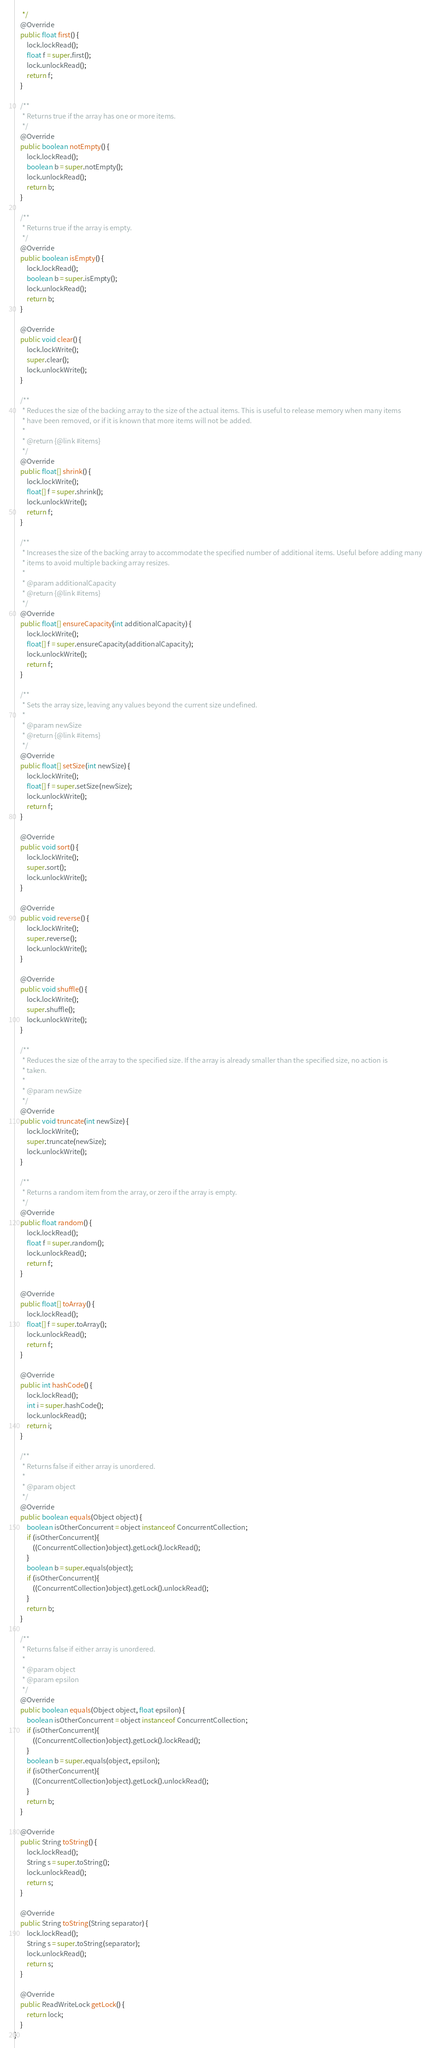<code> <loc_0><loc_0><loc_500><loc_500><_Java_>     */
    @Override
    public float first() {
        lock.lockRead();
        float f = super.first();
        lock.unlockRead();
        return f;
    }

    /**
     * Returns true if the array has one or more items.
     */
    @Override
    public boolean notEmpty() {
        lock.lockRead();
        boolean b = super.notEmpty();
        lock.unlockRead();
        return b;
    }

    /**
     * Returns true if the array is empty.
     */
    @Override
    public boolean isEmpty() {
        lock.lockRead();
        boolean b = super.isEmpty();
        lock.unlockRead();
        return b;
    }

    @Override
    public void clear() {
        lock.lockWrite();
        super.clear();
        lock.unlockWrite();
    }

    /**
     * Reduces the size of the backing array to the size of the actual items. This is useful to release memory when many items
     * have been removed, or if it is known that more items will not be added.
     *
     * @return {@link #items}
     */
    @Override
    public float[] shrink() {
        lock.lockWrite();
        float[] f = super.shrink();
        lock.unlockWrite();
        return f;
    }

    /**
     * Increases the size of the backing array to accommodate the specified number of additional items. Useful before adding many
     * items to avoid multiple backing array resizes.
     *
     * @param additionalCapacity
     * @return {@link #items}
     */
    @Override
    public float[] ensureCapacity(int additionalCapacity) {
        lock.lockWrite();
        float[] f = super.ensureCapacity(additionalCapacity);
        lock.unlockWrite();
        return f;
    }

    /**
     * Sets the array size, leaving any values beyond the current size undefined.
     *
     * @param newSize
     * @return {@link #items}
     */
    @Override
    public float[] setSize(int newSize) {
        lock.lockWrite();
        float[] f = super.setSize(newSize);
        lock.unlockWrite();
        return f;
    }

    @Override
    public void sort() {
        lock.lockWrite();
        super.sort();
        lock.unlockWrite();
    }

    @Override
    public void reverse() {
        lock.lockWrite();
        super.reverse();
        lock.unlockWrite();
    }

    @Override
    public void shuffle() {
        lock.lockWrite();
        super.shuffle();
        lock.unlockWrite();
    }

    /**
     * Reduces the size of the array to the specified size. If the array is already smaller than the specified size, no action is
     * taken.
     *
     * @param newSize
     */
    @Override
    public void truncate(int newSize) {
        lock.lockWrite();
        super.truncate(newSize);
        lock.unlockWrite();
    }

    /**
     * Returns a random item from the array, or zero if the array is empty.
     */
    @Override
    public float random() {
        lock.lockRead();
        float f = super.random();
        lock.unlockRead();
        return f;
    }

    @Override
    public float[] toArray() {
        lock.lockRead();
        float[] f = super.toArray();
        lock.unlockRead();
        return f;
    }

    @Override
    public int hashCode() {
        lock.lockRead();
        int i = super.hashCode();
        lock.unlockRead();
        return i;
    }

    /**
     * Returns false if either array is unordered.
     *
     * @param object
     */
    @Override
    public boolean equals(Object object) {
        boolean isOtherConcurrent = object instanceof ConcurrentCollection;
        if (isOtherConcurrent){
            ((ConcurrentCollection)object).getLock().lockRead();
        }
        boolean b = super.equals(object);
        if (isOtherConcurrent){
            ((ConcurrentCollection)object).getLock().unlockRead();
        }
        return b;
    }

    /**
     * Returns false if either array is unordered.
     *
     * @param object
     * @param epsilon
     */
    @Override
    public boolean equals(Object object, float epsilon) {
        boolean isOtherConcurrent = object instanceof ConcurrentCollection;
        if (isOtherConcurrent){
            ((ConcurrentCollection)object).getLock().lockRead();
        }
        boolean b = super.equals(object, epsilon);
        if (isOtherConcurrent){
            ((ConcurrentCollection)object).getLock().unlockRead();
        }
        return b;
    }

    @Override
    public String toString() {
        lock.lockRead();
        String s = super.toString();
        lock.unlockRead();
        return s;
    }

    @Override
    public String toString(String separator) {
        lock.lockRead();
        String s = super.toString(separator);
        lock.unlockRead();
        return s;
    }

    @Override
    public ReadWriteLock getLock() {
        return lock;
    }
}
</code> 